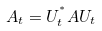Convert formula to latex. <formula><loc_0><loc_0><loc_500><loc_500>A _ { t } = U _ { t } ^ { ^ { * } } A U _ { t }</formula> 